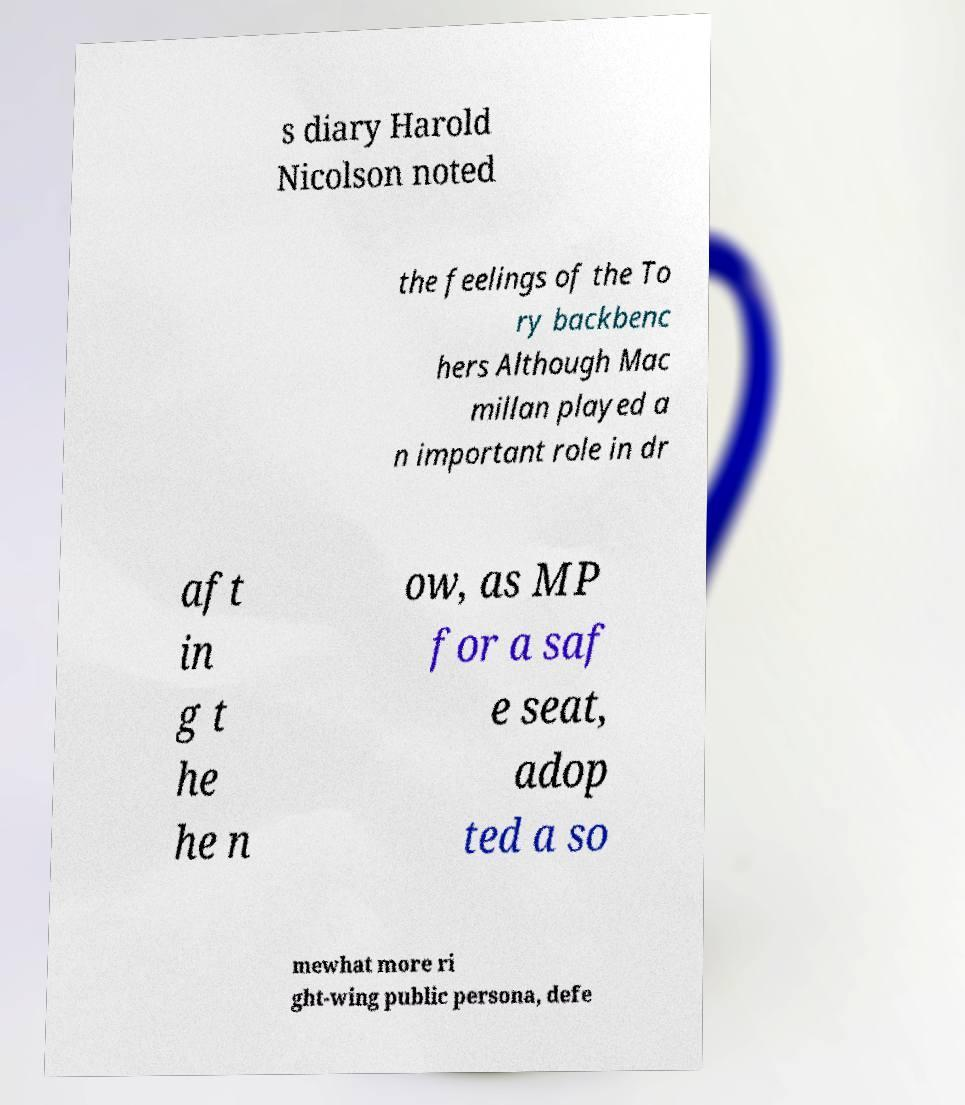Please identify and transcribe the text found in this image. s diary Harold Nicolson noted the feelings of the To ry backbenc hers Although Mac millan played a n important role in dr aft in g t he he n ow, as MP for a saf e seat, adop ted a so mewhat more ri ght-wing public persona, defe 